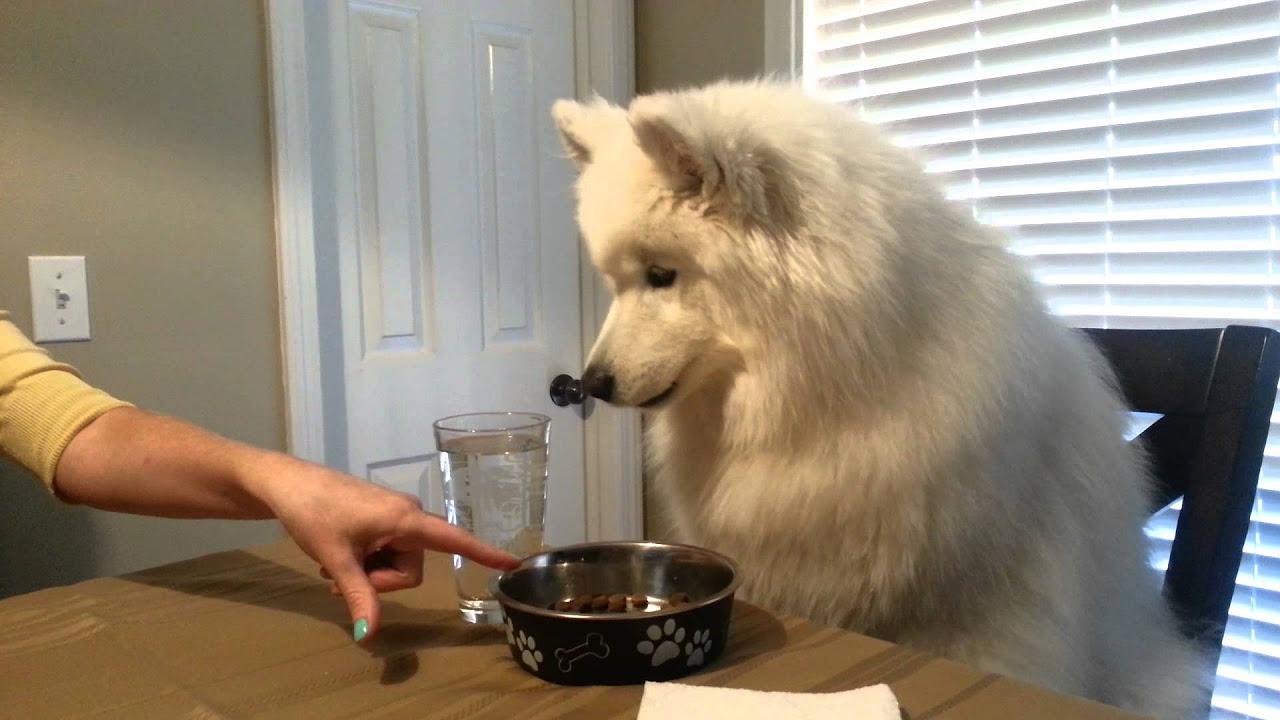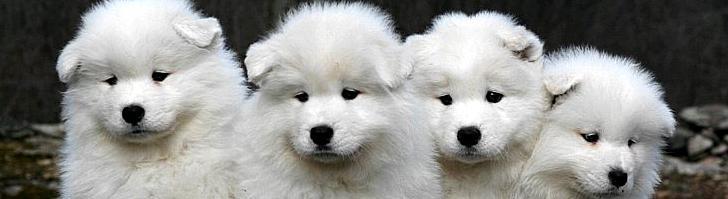The first image is the image on the left, the second image is the image on the right. For the images displayed, is the sentence "Each image contains a single white dog, and at least one image features a dog standing on all fours with its body turned leftward." factually correct? Answer yes or no. No. The first image is the image on the left, the second image is the image on the right. Assess this claim about the two images: "One of the images features a dog eating at a dinner table.". Correct or not? Answer yes or no. Yes. 